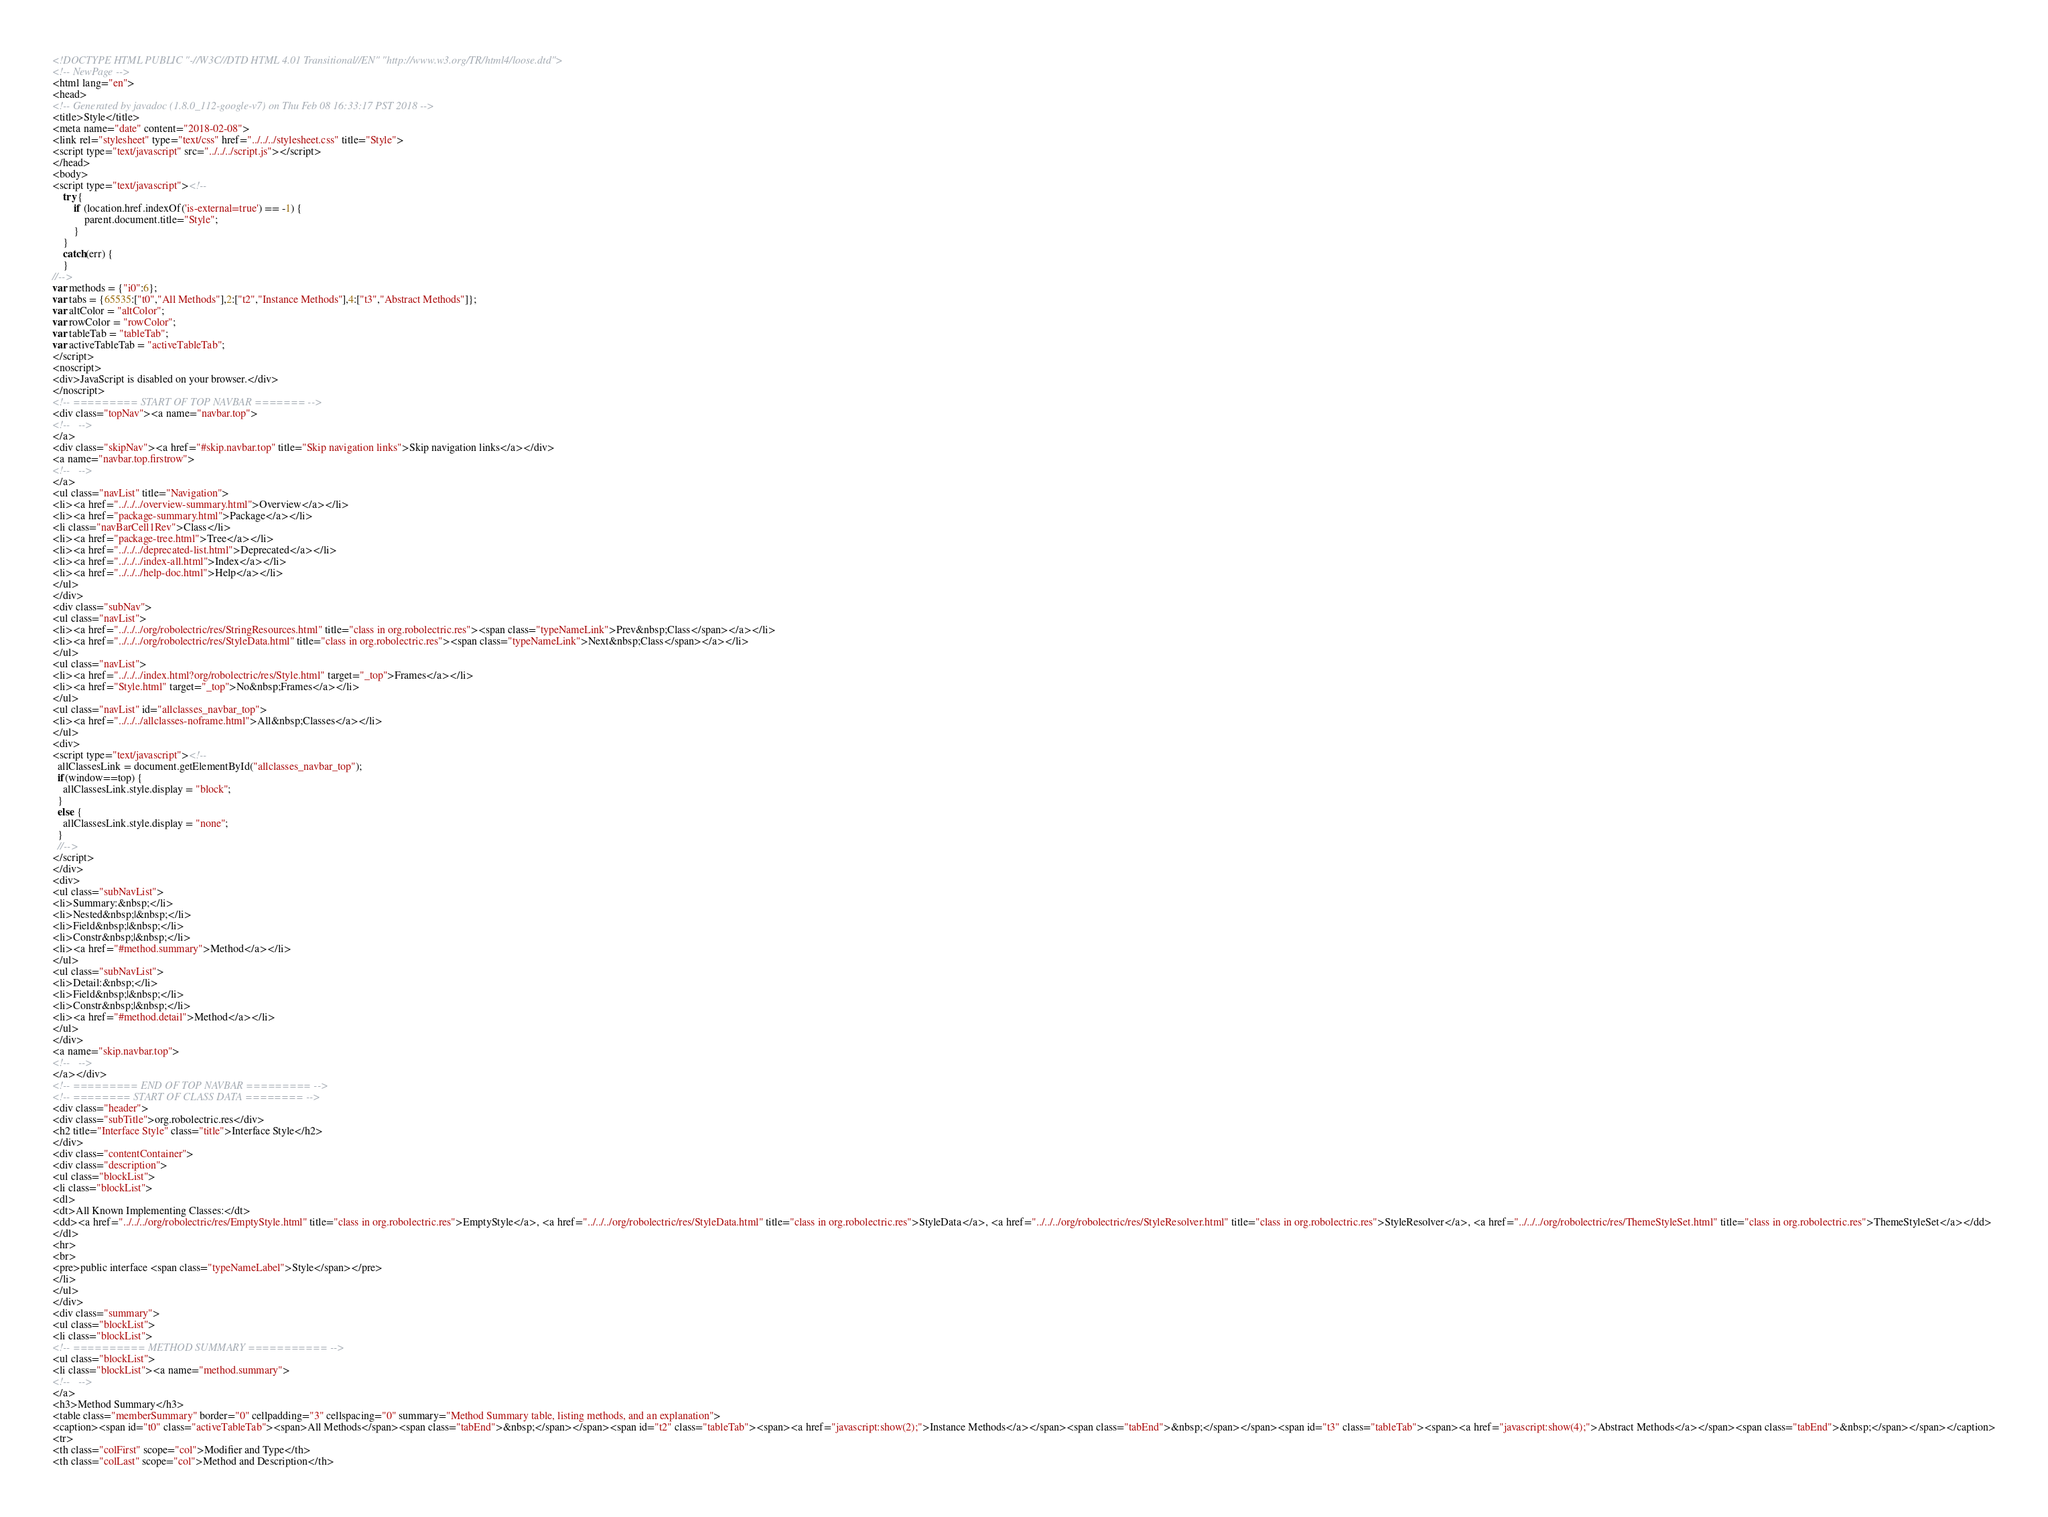Convert code to text. <code><loc_0><loc_0><loc_500><loc_500><_HTML_><!DOCTYPE HTML PUBLIC "-//W3C//DTD HTML 4.01 Transitional//EN" "http://www.w3.org/TR/html4/loose.dtd">
<!-- NewPage -->
<html lang="en">
<head>
<!-- Generated by javadoc (1.8.0_112-google-v7) on Thu Feb 08 16:33:17 PST 2018 -->
<title>Style</title>
<meta name="date" content="2018-02-08">
<link rel="stylesheet" type="text/css" href="../../../stylesheet.css" title="Style">
<script type="text/javascript" src="../../../script.js"></script>
</head>
<body>
<script type="text/javascript"><!--
    try {
        if (location.href.indexOf('is-external=true') == -1) {
            parent.document.title="Style";
        }
    }
    catch(err) {
    }
//-->
var methods = {"i0":6};
var tabs = {65535:["t0","All Methods"],2:["t2","Instance Methods"],4:["t3","Abstract Methods"]};
var altColor = "altColor";
var rowColor = "rowColor";
var tableTab = "tableTab";
var activeTableTab = "activeTableTab";
</script>
<noscript>
<div>JavaScript is disabled on your browser.</div>
</noscript>
<!-- ========= START OF TOP NAVBAR ======= -->
<div class="topNav"><a name="navbar.top">
<!--   -->
</a>
<div class="skipNav"><a href="#skip.navbar.top" title="Skip navigation links">Skip navigation links</a></div>
<a name="navbar.top.firstrow">
<!--   -->
</a>
<ul class="navList" title="Navigation">
<li><a href="../../../overview-summary.html">Overview</a></li>
<li><a href="package-summary.html">Package</a></li>
<li class="navBarCell1Rev">Class</li>
<li><a href="package-tree.html">Tree</a></li>
<li><a href="../../../deprecated-list.html">Deprecated</a></li>
<li><a href="../../../index-all.html">Index</a></li>
<li><a href="../../../help-doc.html">Help</a></li>
</ul>
</div>
<div class="subNav">
<ul class="navList">
<li><a href="../../../org/robolectric/res/StringResources.html" title="class in org.robolectric.res"><span class="typeNameLink">Prev&nbsp;Class</span></a></li>
<li><a href="../../../org/robolectric/res/StyleData.html" title="class in org.robolectric.res"><span class="typeNameLink">Next&nbsp;Class</span></a></li>
</ul>
<ul class="navList">
<li><a href="../../../index.html?org/robolectric/res/Style.html" target="_top">Frames</a></li>
<li><a href="Style.html" target="_top">No&nbsp;Frames</a></li>
</ul>
<ul class="navList" id="allclasses_navbar_top">
<li><a href="../../../allclasses-noframe.html">All&nbsp;Classes</a></li>
</ul>
<div>
<script type="text/javascript"><!--
  allClassesLink = document.getElementById("allclasses_navbar_top");
  if(window==top) {
    allClassesLink.style.display = "block";
  }
  else {
    allClassesLink.style.display = "none";
  }
  //-->
</script>
</div>
<div>
<ul class="subNavList">
<li>Summary:&nbsp;</li>
<li>Nested&nbsp;|&nbsp;</li>
<li>Field&nbsp;|&nbsp;</li>
<li>Constr&nbsp;|&nbsp;</li>
<li><a href="#method.summary">Method</a></li>
</ul>
<ul class="subNavList">
<li>Detail:&nbsp;</li>
<li>Field&nbsp;|&nbsp;</li>
<li>Constr&nbsp;|&nbsp;</li>
<li><a href="#method.detail">Method</a></li>
</ul>
</div>
<a name="skip.navbar.top">
<!--   -->
</a></div>
<!-- ========= END OF TOP NAVBAR ========= -->
<!-- ======== START OF CLASS DATA ======== -->
<div class="header">
<div class="subTitle">org.robolectric.res</div>
<h2 title="Interface Style" class="title">Interface Style</h2>
</div>
<div class="contentContainer">
<div class="description">
<ul class="blockList">
<li class="blockList">
<dl>
<dt>All Known Implementing Classes:</dt>
<dd><a href="../../../org/robolectric/res/EmptyStyle.html" title="class in org.robolectric.res">EmptyStyle</a>, <a href="../../../org/robolectric/res/StyleData.html" title="class in org.robolectric.res">StyleData</a>, <a href="../../../org/robolectric/res/StyleResolver.html" title="class in org.robolectric.res">StyleResolver</a>, <a href="../../../org/robolectric/res/ThemeStyleSet.html" title="class in org.robolectric.res">ThemeStyleSet</a></dd>
</dl>
<hr>
<br>
<pre>public interface <span class="typeNameLabel">Style</span></pre>
</li>
</ul>
</div>
<div class="summary">
<ul class="blockList">
<li class="blockList">
<!-- ========== METHOD SUMMARY =========== -->
<ul class="blockList">
<li class="blockList"><a name="method.summary">
<!--   -->
</a>
<h3>Method Summary</h3>
<table class="memberSummary" border="0" cellpadding="3" cellspacing="0" summary="Method Summary table, listing methods, and an explanation">
<caption><span id="t0" class="activeTableTab"><span>All Methods</span><span class="tabEnd">&nbsp;</span></span><span id="t2" class="tableTab"><span><a href="javascript:show(2);">Instance Methods</a></span><span class="tabEnd">&nbsp;</span></span><span id="t3" class="tableTab"><span><a href="javascript:show(4);">Abstract Methods</a></span><span class="tabEnd">&nbsp;</span></span></caption>
<tr>
<th class="colFirst" scope="col">Modifier and Type</th>
<th class="colLast" scope="col">Method and Description</th></code> 